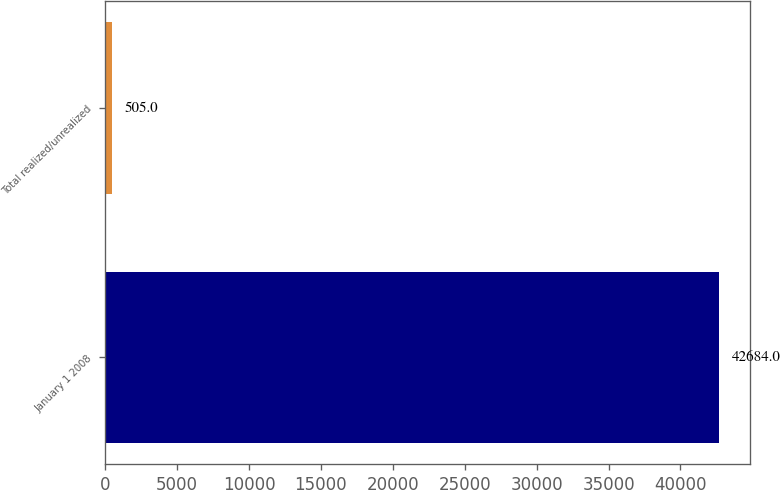Convert chart to OTSL. <chart><loc_0><loc_0><loc_500><loc_500><bar_chart><fcel>January 1 2008<fcel>Total realized/unrealized<nl><fcel>42684<fcel>505<nl></chart> 